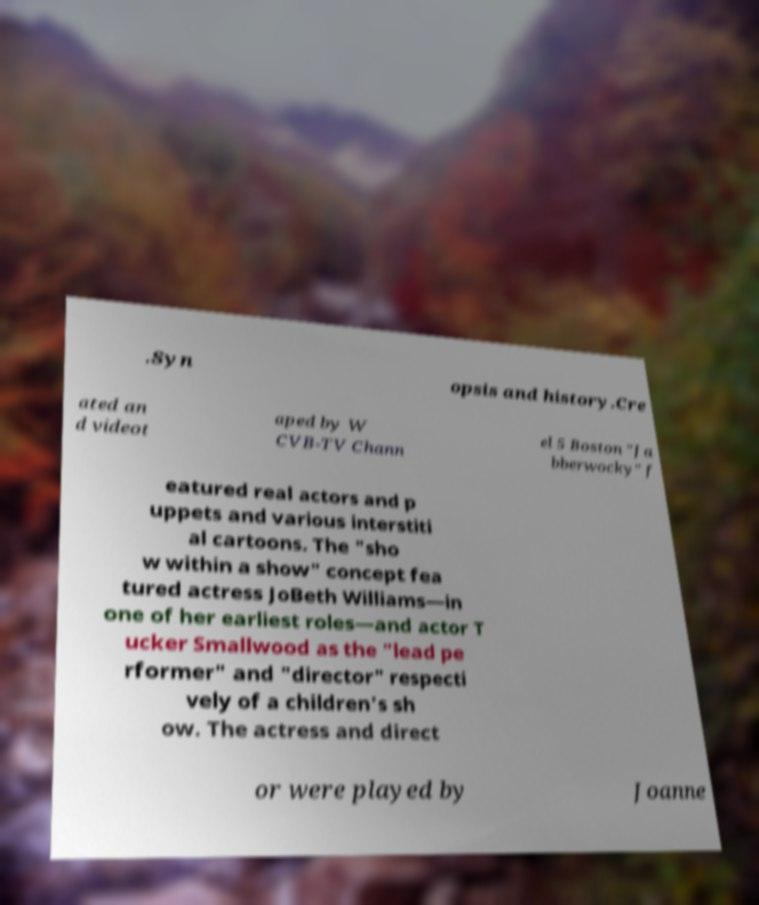Please read and relay the text visible in this image. What does it say? .Syn opsis and history.Cre ated an d videot aped by W CVB-TV Chann el 5 Boston "Ja bberwocky" f eatured real actors and p uppets and various interstiti al cartoons. The "sho w within a show" concept fea tured actress JoBeth Williams—in one of her earliest roles—and actor T ucker Smallwood as the "lead pe rformer" and "director" respecti vely of a children's sh ow. The actress and direct or were played by Joanne 